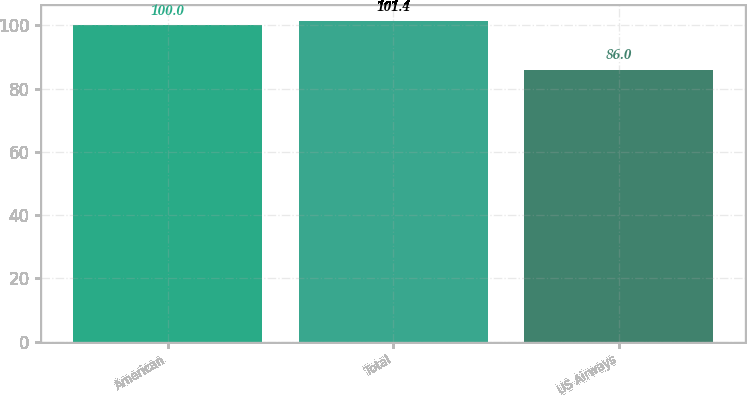Convert chart to OTSL. <chart><loc_0><loc_0><loc_500><loc_500><bar_chart><fcel>American<fcel>Total<fcel>US Airways<nl><fcel>100<fcel>101.4<fcel>86<nl></chart> 